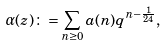<formula> <loc_0><loc_0><loc_500><loc_500>\alpha ( z ) \colon = \sum _ { n \geq 0 } { a } ( n ) q ^ { n - \frac { 1 } { 2 4 } } ,</formula> 